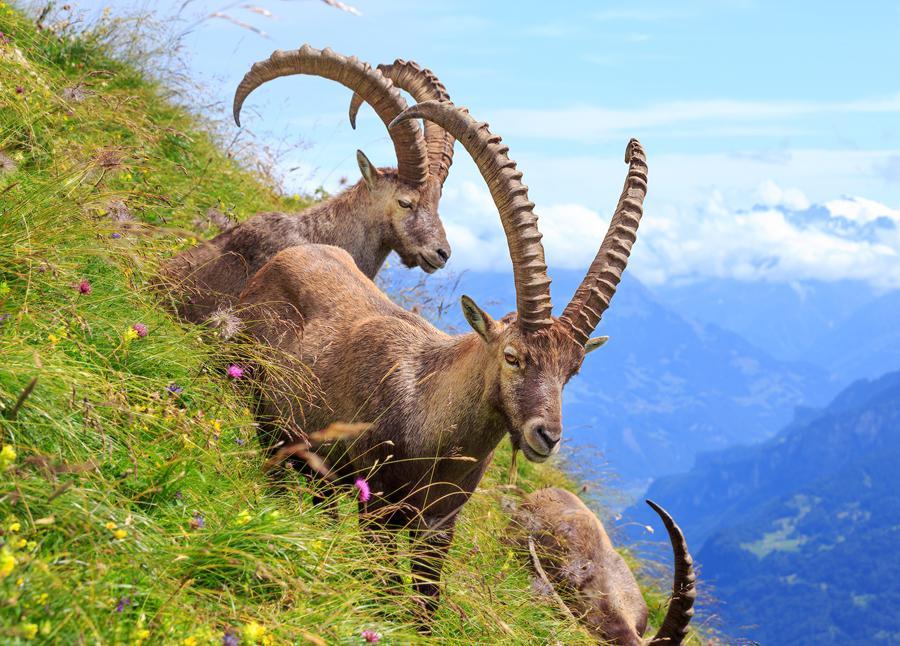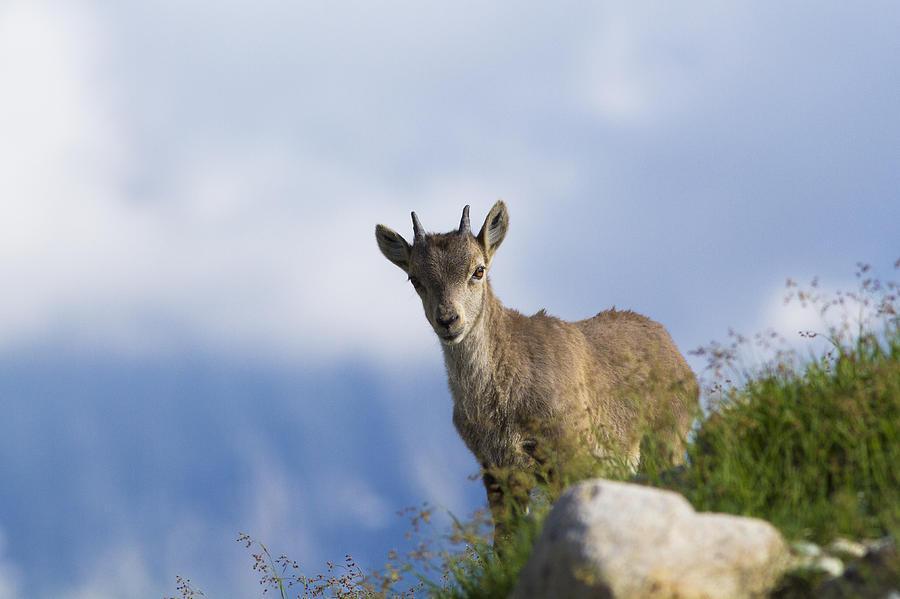The first image is the image on the left, the second image is the image on the right. Analyze the images presented: Is the assertion "Each individual image has exactly one animal in it." valid? Answer yes or no. No. The first image is the image on the left, the second image is the image on the right. Examine the images to the left and right. Is the description "there are two sheep in the image pair" accurate? Answer yes or no. No. 